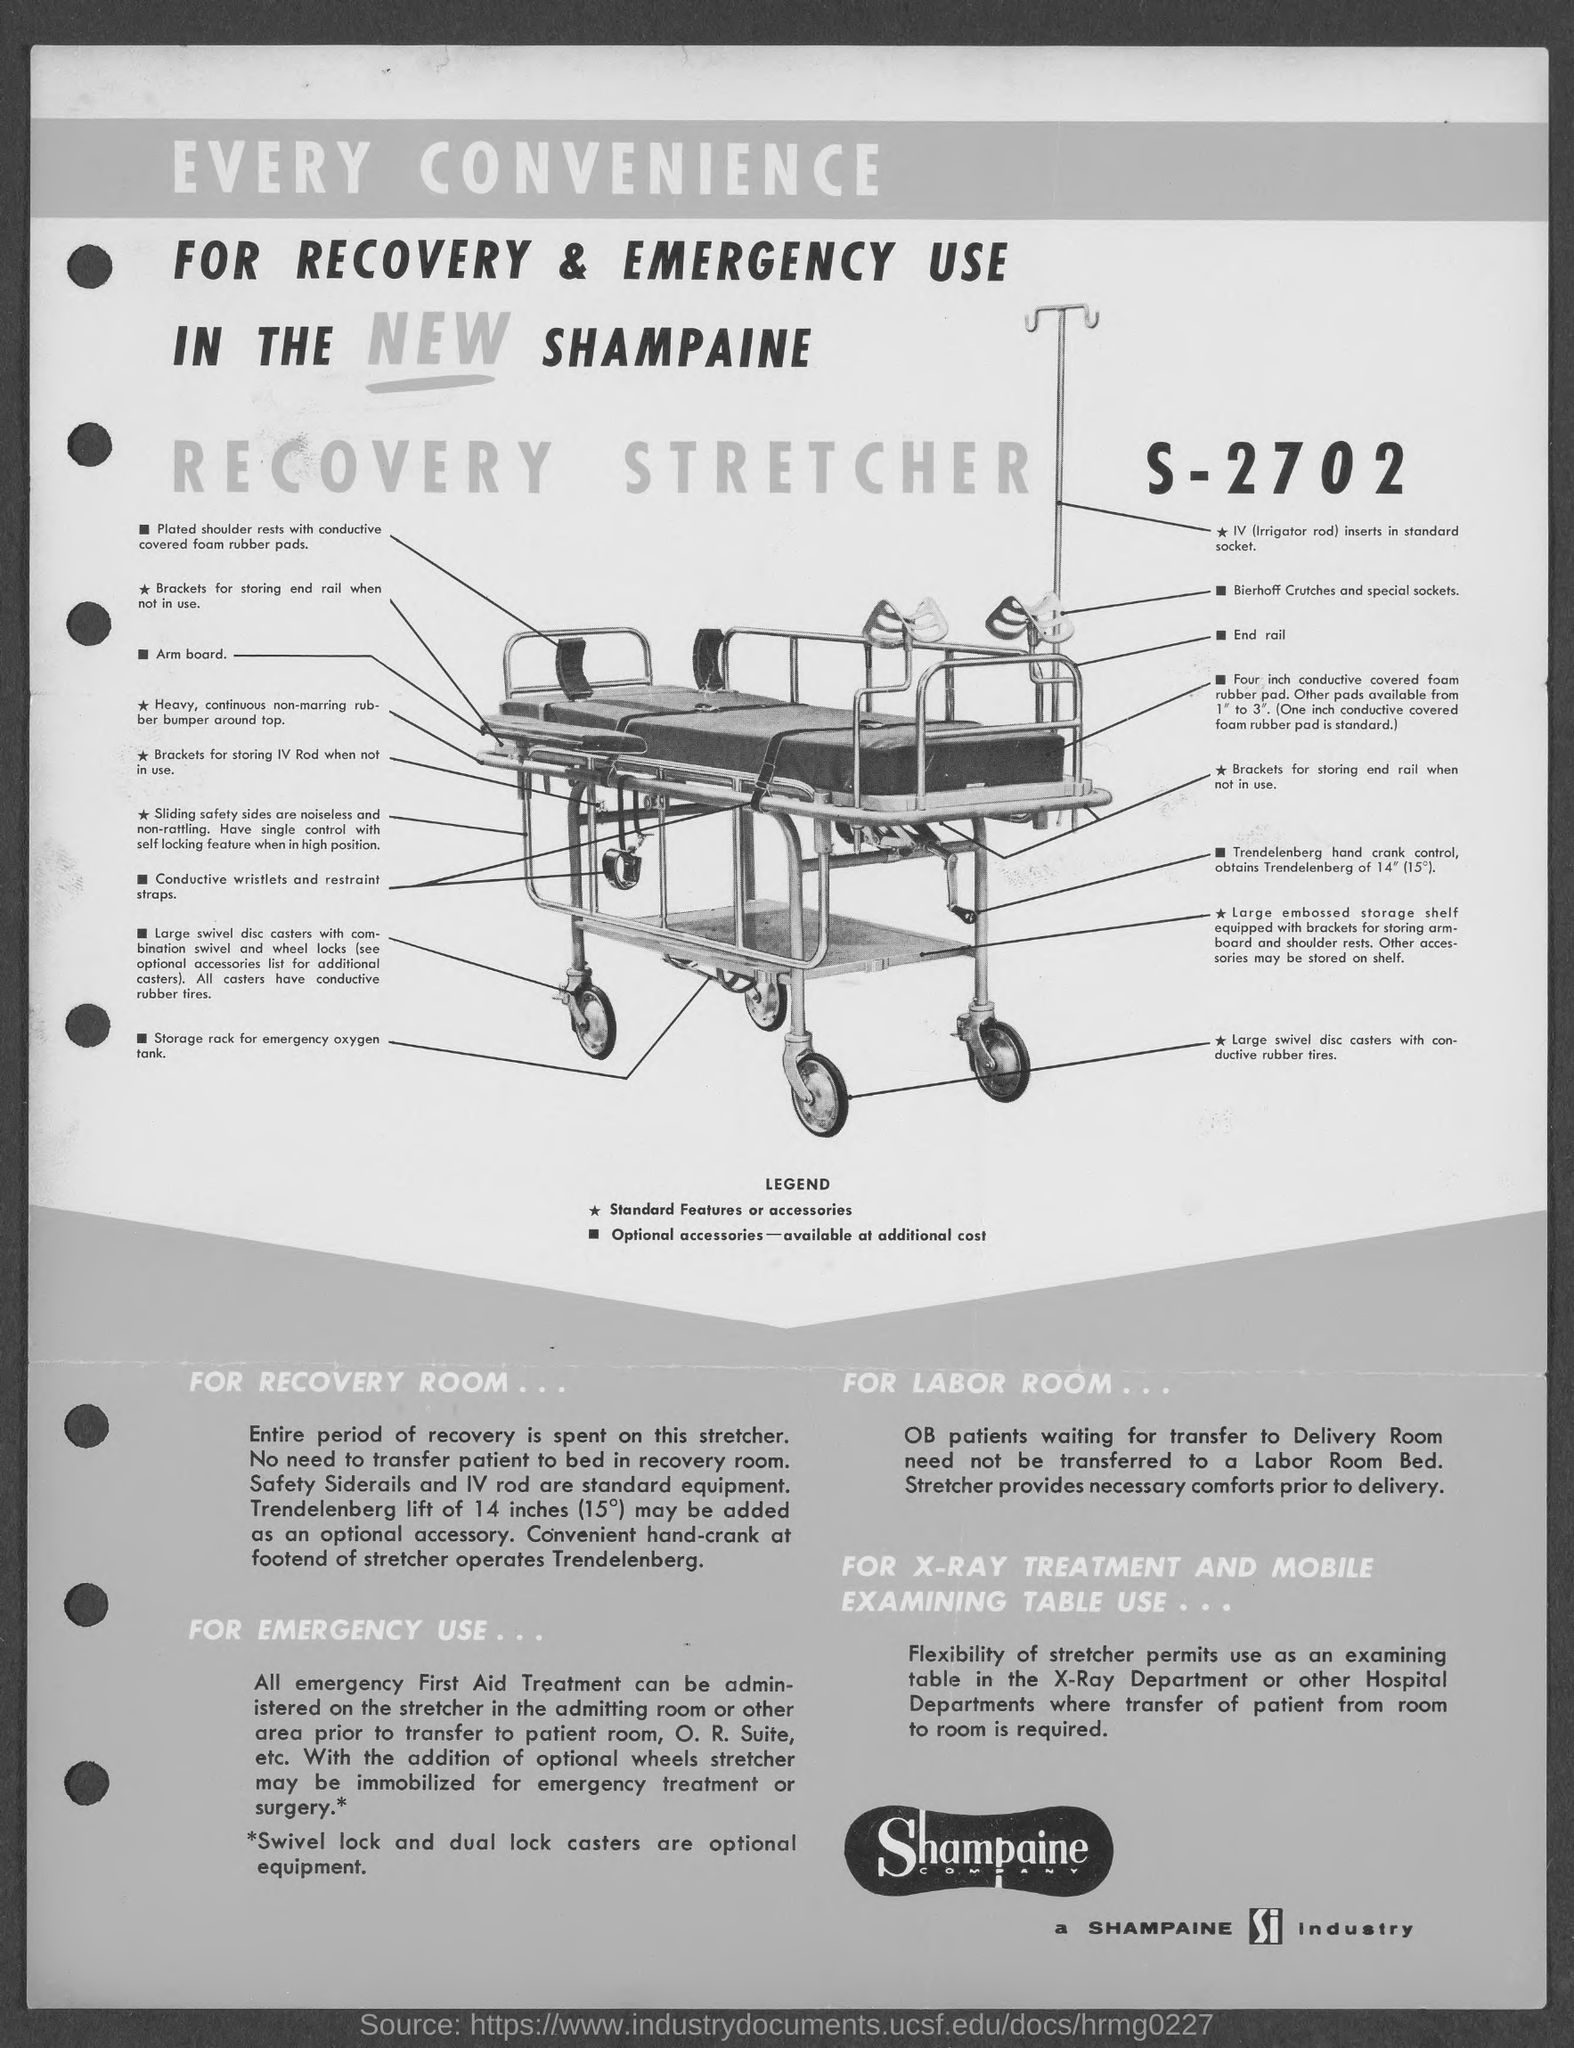What is the first title in the document?
Ensure brevity in your answer.  Every Convenience. What is the second title in the document?
Your answer should be very brief. FOR RECOVERY & EMERGENCY USE. What is the third title in the document?
Your answer should be very brief. In the new shampaine. What is the fourth title in the document?
Ensure brevity in your answer.  Recovery Stretcher. What is the number at the top right of the document?
Offer a very short reply. S-2702. 